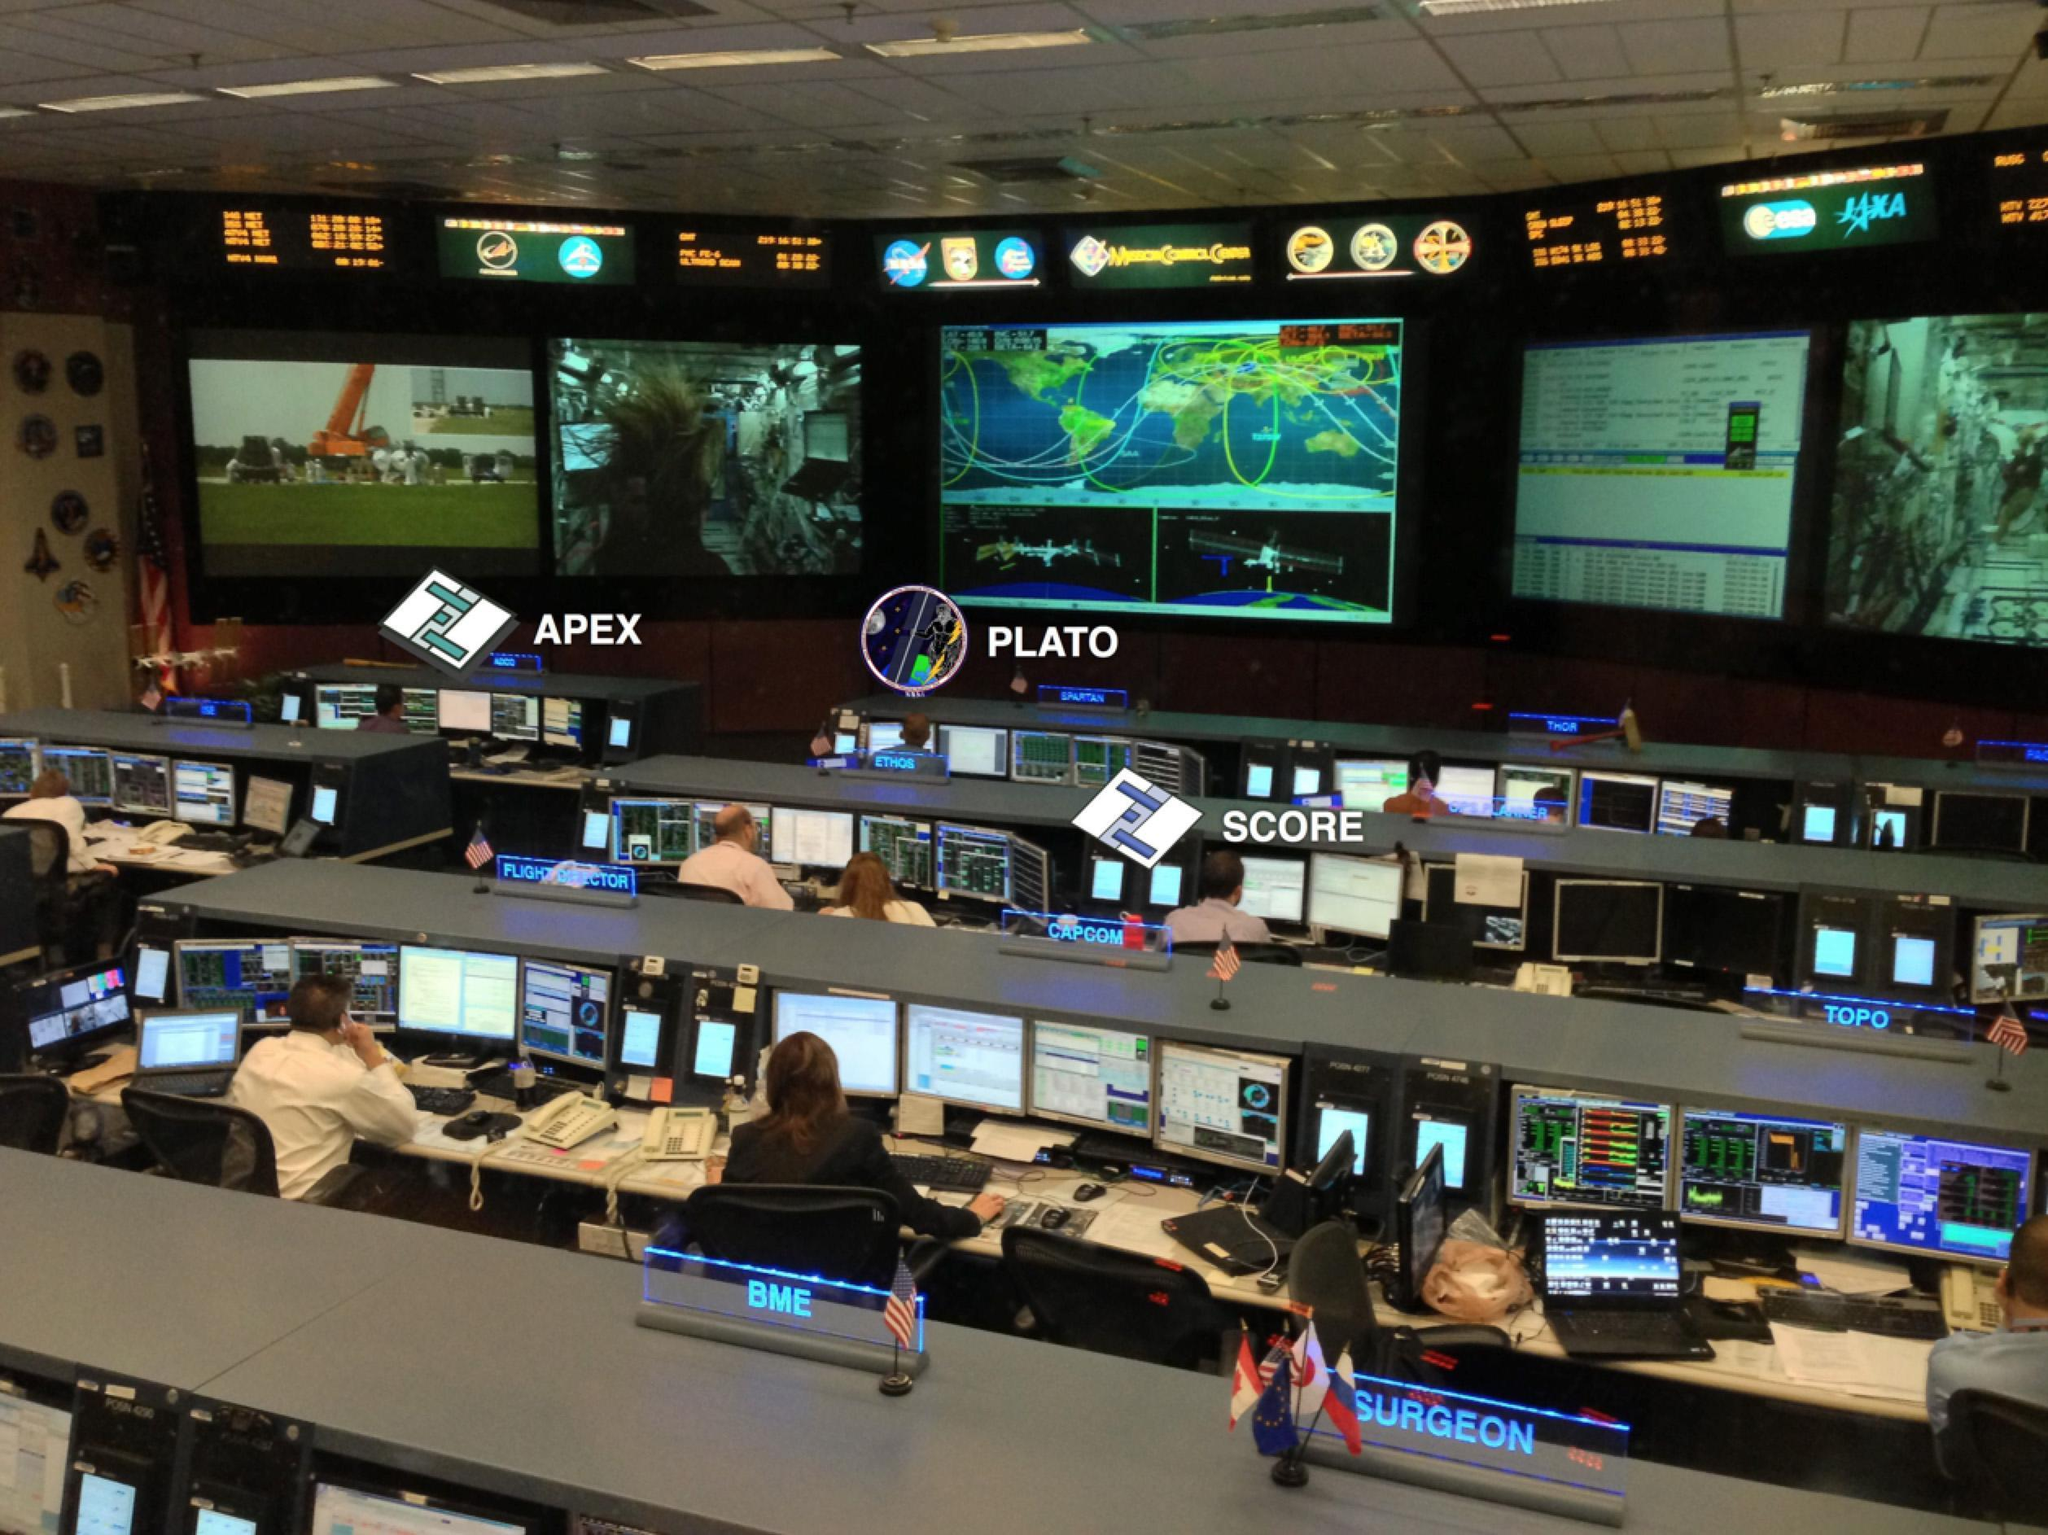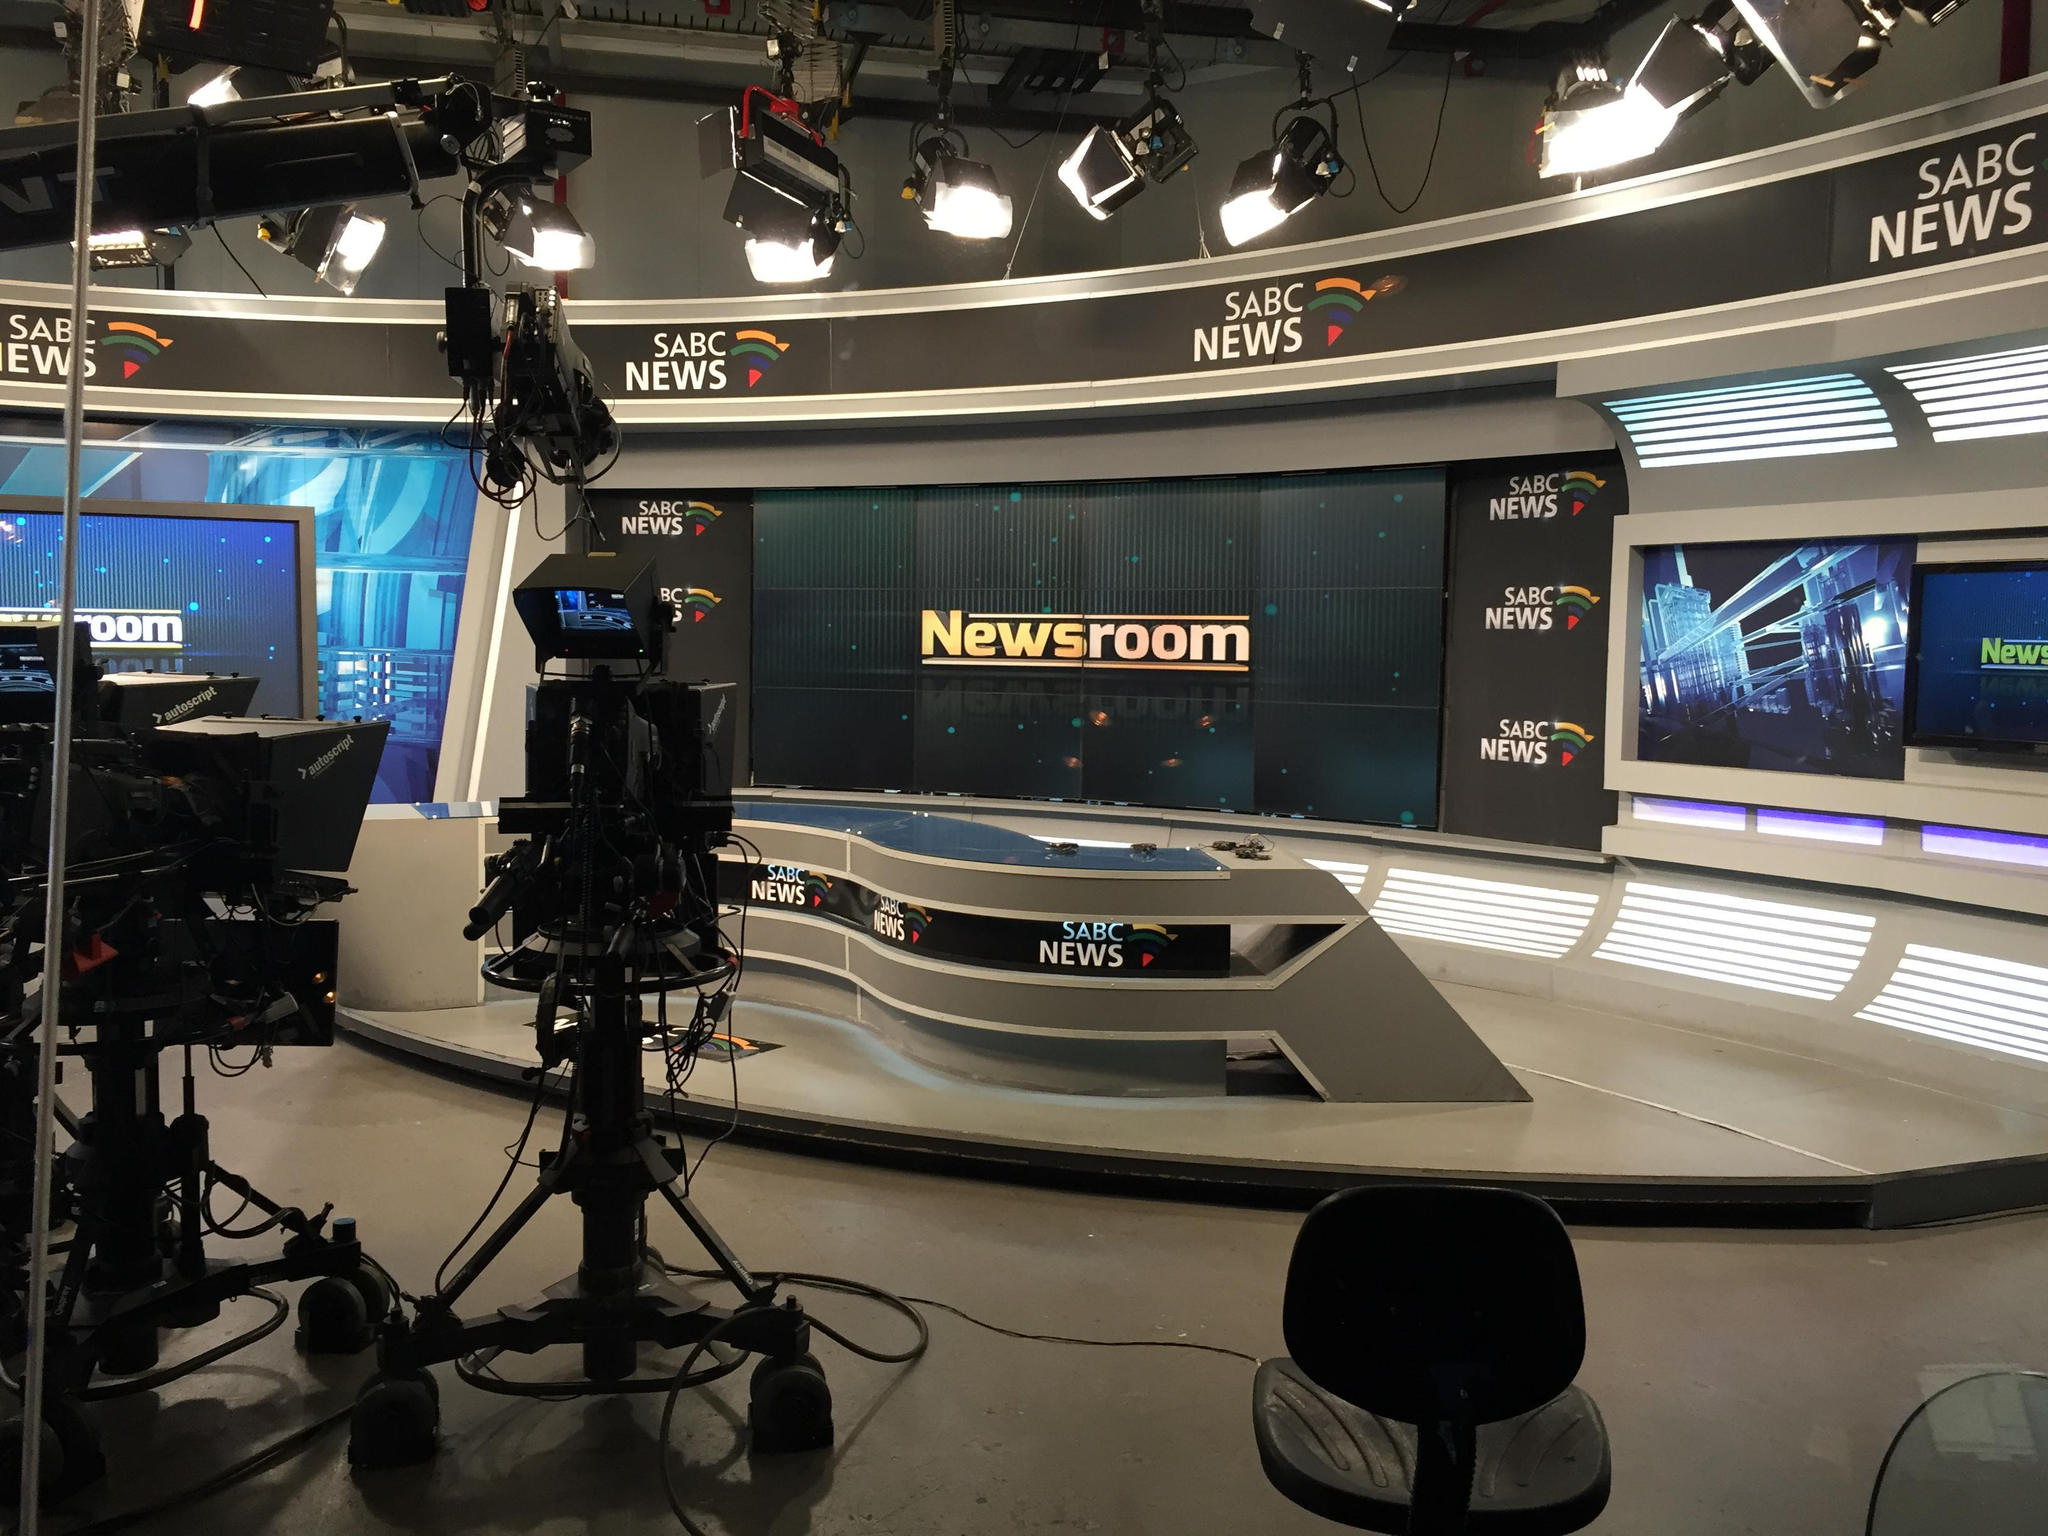The first image is the image on the left, the second image is the image on the right. Given the left and right images, does the statement "In at least one of the images, humans are present, probably discussing how best to deliver the news." hold true? Answer yes or no. Yes. The first image is the image on the left, the second image is the image on the right. Evaluate the accuracy of this statement regarding the images: "At least one image includes people facing large screens in front of them.". Is it true? Answer yes or no. Yes. 